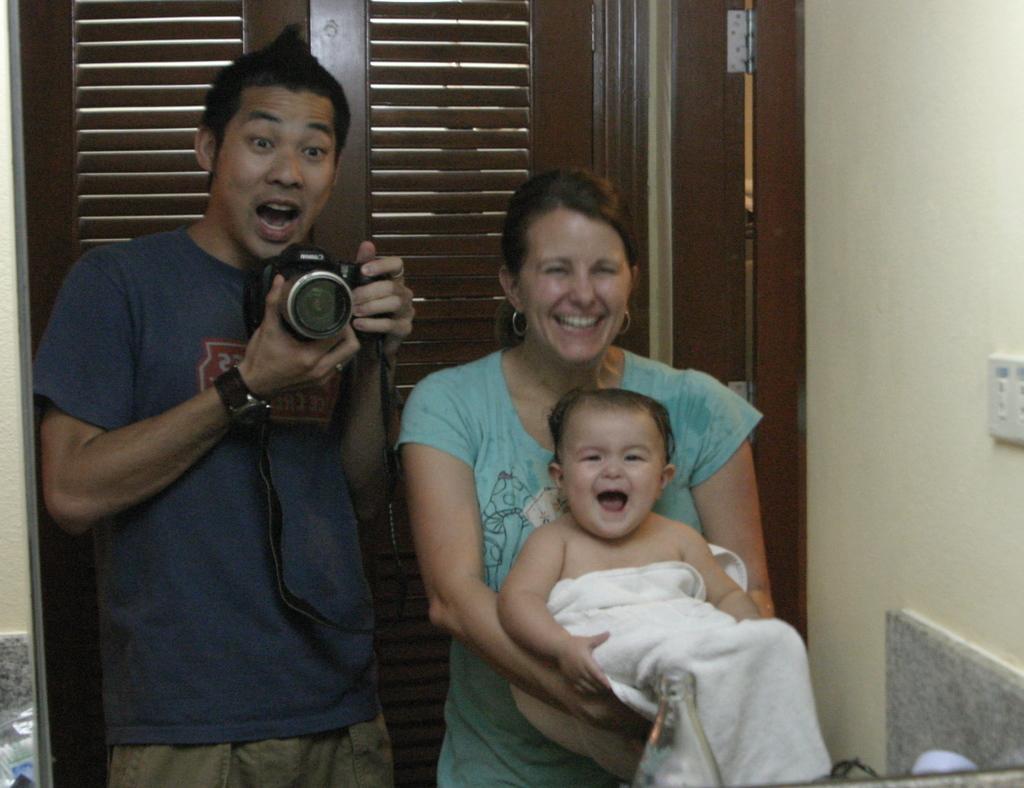How would you summarize this image in a sentence or two? In the image we can see there are people who are standing and a man is holding camera in his hand and a woman is holding baby in her hand. 